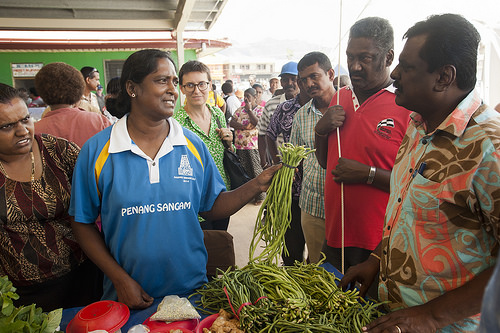<image>
Is the man to the left of the women? No. The man is not to the left of the women. From this viewpoint, they have a different horizontal relationship. 